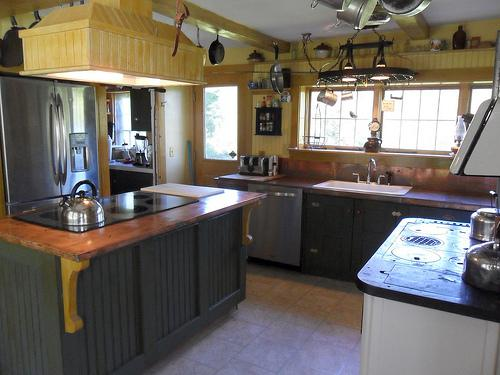Question: where is this picture taken?
Choices:
A. Dining room.
B. A kitchen.
C. Living room.
D. Bedroom.
Answer with the letter. Answer: B Question: what color are the cabinets?
Choices:
A. Brown.
B. Blue.
C. Green.
D. Yellow.
Answer with the letter. Answer: A Question: how many sinks are in the picture?
Choices:
A. 3.
B. 2.
C. 4.
D. 5.
Answer with the letter. Answer: B Question: where are the tea kettles at?
Choices:
A. Stove.
B. Dining table.
C. On the counter.
D. Coffee table.
Answer with the letter. Answer: C Question: how many people are in the picture?
Choices:
A. Two.
B. Zero.
C. Three.
D. Four.
Answer with the letter. Answer: B 